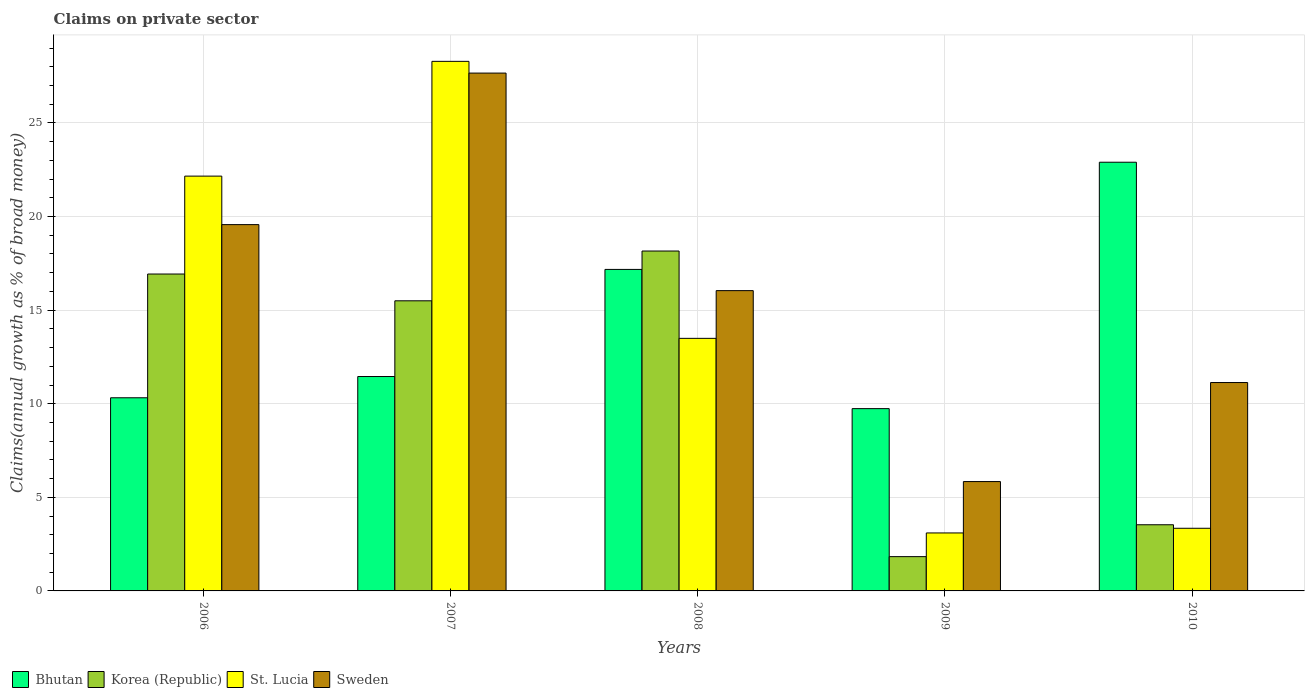How many different coloured bars are there?
Keep it short and to the point. 4. How many groups of bars are there?
Offer a terse response. 5. Are the number of bars on each tick of the X-axis equal?
Your answer should be very brief. Yes. How many bars are there on the 3rd tick from the left?
Give a very brief answer. 4. How many bars are there on the 3rd tick from the right?
Offer a very short reply. 4. What is the label of the 3rd group of bars from the left?
Provide a short and direct response. 2008. In how many cases, is the number of bars for a given year not equal to the number of legend labels?
Keep it short and to the point. 0. What is the percentage of broad money claimed on private sector in St. Lucia in 2008?
Offer a terse response. 13.49. Across all years, what is the maximum percentage of broad money claimed on private sector in Korea (Republic)?
Provide a succinct answer. 18.16. Across all years, what is the minimum percentage of broad money claimed on private sector in Bhutan?
Make the answer very short. 9.74. In which year was the percentage of broad money claimed on private sector in St. Lucia minimum?
Your answer should be very brief. 2009. What is the total percentage of broad money claimed on private sector in Bhutan in the graph?
Make the answer very short. 71.59. What is the difference between the percentage of broad money claimed on private sector in Bhutan in 2007 and that in 2008?
Your answer should be compact. -5.72. What is the difference between the percentage of broad money claimed on private sector in Bhutan in 2007 and the percentage of broad money claimed on private sector in St. Lucia in 2006?
Your response must be concise. -10.71. What is the average percentage of broad money claimed on private sector in Sweden per year?
Your response must be concise. 16.05. In the year 2009, what is the difference between the percentage of broad money claimed on private sector in St. Lucia and percentage of broad money claimed on private sector in Korea (Republic)?
Offer a terse response. 1.27. What is the ratio of the percentage of broad money claimed on private sector in Bhutan in 2006 to that in 2010?
Make the answer very short. 0.45. Is the difference between the percentage of broad money claimed on private sector in St. Lucia in 2008 and 2009 greater than the difference between the percentage of broad money claimed on private sector in Korea (Republic) in 2008 and 2009?
Offer a terse response. No. What is the difference between the highest and the second highest percentage of broad money claimed on private sector in Bhutan?
Keep it short and to the point. 5.73. What is the difference between the highest and the lowest percentage of broad money claimed on private sector in Korea (Republic)?
Your answer should be compact. 16.33. In how many years, is the percentage of broad money claimed on private sector in St. Lucia greater than the average percentage of broad money claimed on private sector in St. Lucia taken over all years?
Your answer should be very brief. 2. What does the 3rd bar from the left in 2008 represents?
Offer a very short reply. St. Lucia. What does the 4th bar from the right in 2007 represents?
Offer a very short reply. Bhutan. Are all the bars in the graph horizontal?
Ensure brevity in your answer.  No. Are the values on the major ticks of Y-axis written in scientific E-notation?
Provide a succinct answer. No. Does the graph contain any zero values?
Your answer should be very brief. No. Does the graph contain grids?
Offer a terse response. Yes. What is the title of the graph?
Provide a succinct answer. Claims on private sector. Does "Turkmenistan" appear as one of the legend labels in the graph?
Your response must be concise. No. What is the label or title of the Y-axis?
Your answer should be very brief. Claims(annual growth as % of broad money). What is the Claims(annual growth as % of broad money) in Bhutan in 2006?
Give a very brief answer. 10.32. What is the Claims(annual growth as % of broad money) in Korea (Republic) in 2006?
Your answer should be very brief. 16.93. What is the Claims(annual growth as % of broad money) in St. Lucia in 2006?
Keep it short and to the point. 22.16. What is the Claims(annual growth as % of broad money) of Sweden in 2006?
Your answer should be compact. 19.57. What is the Claims(annual growth as % of broad money) in Bhutan in 2007?
Make the answer very short. 11.45. What is the Claims(annual growth as % of broad money) of Korea (Republic) in 2007?
Make the answer very short. 15.5. What is the Claims(annual growth as % of broad money) of St. Lucia in 2007?
Your response must be concise. 28.29. What is the Claims(annual growth as % of broad money) of Sweden in 2007?
Your response must be concise. 27.66. What is the Claims(annual growth as % of broad money) in Bhutan in 2008?
Provide a short and direct response. 17.18. What is the Claims(annual growth as % of broad money) in Korea (Republic) in 2008?
Your response must be concise. 18.16. What is the Claims(annual growth as % of broad money) of St. Lucia in 2008?
Your answer should be compact. 13.49. What is the Claims(annual growth as % of broad money) in Sweden in 2008?
Keep it short and to the point. 16.04. What is the Claims(annual growth as % of broad money) in Bhutan in 2009?
Make the answer very short. 9.74. What is the Claims(annual growth as % of broad money) in Korea (Republic) in 2009?
Provide a short and direct response. 1.83. What is the Claims(annual growth as % of broad money) in St. Lucia in 2009?
Provide a succinct answer. 3.1. What is the Claims(annual growth as % of broad money) of Sweden in 2009?
Offer a very short reply. 5.84. What is the Claims(annual growth as % of broad money) of Bhutan in 2010?
Your answer should be compact. 22.9. What is the Claims(annual growth as % of broad money) in Korea (Republic) in 2010?
Provide a succinct answer. 3.53. What is the Claims(annual growth as % of broad money) of St. Lucia in 2010?
Make the answer very short. 3.35. What is the Claims(annual growth as % of broad money) in Sweden in 2010?
Your answer should be very brief. 11.13. Across all years, what is the maximum Claims(annual growth as % of broad money) in Bhutan?
Offer a terse response. 22.9. Across all years, what is the maximum Claims(annual growth as % of broad money) in Korea (Republic)?
Offer a terse response. 18.16. Across all years, what is the maximum Claims(annual growth as % of broad money) in St. Lucia?
Your answer should be compact. 28.29. Across all years, what is the maximum Claims(annual growth as % of broad money) in Sweden?
Offer a very short reply. 27.66. Across all years, what is the minimum Claims(annual growth as % of broad money) in Bhutan?
Offer a terse response. 9.74. Across all years, what is the minimum Claims(annual growth as % of broad money) of Korea (Republic)?
Keep it short and to the point. 1.83. Across all years, what is the minimum Claims(annual growth as % of broad money) in St. Lucia?
Provide a short and direct response. 3.1. Across all years, what is the minimum Claims(annual growth as % of broad money) of Sweden?
Your answer should be very brief. 5.84. What is the total Claims(annual growth as % of broad money) of Bhutan in the graph?
Your response must be concise. 71.59. What is the total Claims(annual growth as % of broad money) in Korea (Republic) in the graph?
Your answer should be compact. 55.95. What is the total Claims(annual growth as % of broad money) of St. Lucia in the graph?
Make the answer very short. 70.39. What is the total Claims(annual growth as % of broad money) of Sweden in the graph?
Keep it short and to the point. 80.25. What is the difference between the Claims(annual growth as % of broad money) of Bhutan in 2006 and that in 2007?
Provide a short and direct response. -1.14. What is the difference between the Claims(annual growth as % of broad money) of Korea (Republic) in 2006 and that in 2007?
Offer a terse response. 1.43. What is the difference between the Claims(annual growth as % of broad money) of St. Lucia in 2006 and that in 2007?
Provide a succinct answer. -6.13. What is the difference between the Claims(annual growth as % of broad money) in Sweden in 2006 and that in 2007?
Your response must be concise. -8.09. What is the difference between the Claims(annual growth as % of broad money) of Bhutan in 2006 and that in 2008?
Your answer should be very brief. -6.86. What is the difference between the Claims(annual growth as % of broad money) in Korea (Republic) in 2006 and that in 2008?
Keep it short and to the point. -1.23. What is the difference between the Claims(annual growth as % of broad money) in St. Lucia in 2006 and that in 2008?
Make the answer very short. 8.67. What is the difference between the Claims(annual growth as % of broad money) of Sweden in 2006 and that in 2008?
Give a very brief answer. 3.53. What is the difference between the Claims(annual growth as % of broad money) in Bhutan in 2006 and that in 2009?
Keep it short and to the point. 0.58. What is the difference between the Claims(annual growth as % of broad money) in Korea (Republic) in 2006 and that in 2009?
Give a very brief answer. 15.1. What is the difference between the Claims(annual growth as % of broad money) of St. Lucia in 2006 and that in 2009?
Make the answer very short. 19.06. What is the difference between the Claims(annual growth as % of broad money) in Sweden in 2006 and that in 2009?
Your answer should be very brief. 13.73. What is the difference between the Claims(annual growth as % of broad money) in Bhutan in 2006 and that in 2010?
Offer a very short reply. -12.58. What is the difference between the Claims(annual growth as % of broad money) of Korea (Republic) in 2006 and that in 2010?
Your answer should be compact. 13.4. What is the difference between the Claims(annual growth as % of broad money) in St. Lucia in 2006 and that in 2010?
Give a very brief answer. 18.81. What is the difference between the Claims(annual growth as % of broad money) of Sweden in 2006 and that in 2010?
Offer a very short reply. 8.44. What is the difference between the Claims(annual growth as % of broad money) of Bhutan in 2007 and that in 2008?
Your response must be concise. -5.72. What is the difference between the Claims(annual growth as % of broad money) of Korea (Republic) in 2007 and that in 2008?
Your response must be concise. -2.66. What is the difference between the Claims(annual growth as % of broad money) of St. Lucia in 2007 and that in 2008?
Your response must be concise. 14.8. What is the difference between the Claims(annual growth as % of broad money) in Sweden in 2007 and that in 2008?
Provide a succinct answer. 11.62. What is the difference between the Claims(annual growth as % of broad money) in Bhutan in 2007 and that in 2009?
Your answer should be compact. 1.72. What is the difference between the Claims(annual growth as % of broad money) of Korea (Republic) in 2007 and that in 2009?
Your answer should be compact. 13.67. What is the difference between the Claims(annual growth as % of broad money) of St. Lucia in 2007 and that in 2009?
Offer a very short reply. 25.19. What is the difference between the Claims(annual growth as % of broad money) of Sweden in 2007 and that in 2009?
Ensure brevity in your answer.  21.82. What is the difference between the Claims(annual growth as % of broad money) of Bhutan in 2007 and that in 2010?
Your response must be concise. -11.45. What is the difference between the Claims(annual growth as % of broad money) of Korea (Republic) in 2007 and that in 2010?
Provide a short and direct response. 11.96. What is the difference between the Claims(annual growth as % of broad money) of St. Lucia in 2007 and that in 2010?
Provide a short and direct response. 24.94. What is the difference between the Claims(annual growth as % of broad money) in Sweden in 2007 and that in 2010?
Give a very brief answer. 16.53. What is the difference between the Claims(annual growth as % of broad money) in Bhutan in 2008 and that in 2009?
Give a very brief answer. 7.44. What is the difference between the Claims(annual growth as % of broad money) of Korea (Republic) in 2008 and that in 2009?
Offer a terse response. 16.33. What is the difference between the Claims(annual growth as % of broad money) in St. Lucia in 2008 and that in 2009?
Make the answer very short. 10.4. What is the difference between the Claims(annual growth as % of broad money) in Sweden in 2008 and that in 2009?
Your response must be concise. 10.2. What is the difference between the Claims(annual growth as % of broad money) in Bhutan in 2008 and that in 2010?
Your answer should be compact. -5.73. What is the difference between the Claims(annual growth as % of broad money) in Korea (Republic) in 2008 and that in 2010?
Your answer should be very brief. 14.62. What is the difference between the Claims(annual growth as % of broad money) in St. Lucia in 2008 and that in 2010?
Ensure brevity in your answer.  10.15. What is the difference between the Claims(annual growth as % of broad money) in Sweden in 2008 and that in 2010?
Provide a short and direct response. 4.91. What is the difference between the Claims(annual growth as % of broad money) in Bhutan in 2009 and that in 2010?
Provide a short and direct response. -13.16. What is the difference between the Claims(annual growth as % of broad money) of Korea (Republic) in 2009 and that in 2010?
Provide a short and direct response. -1.7. What is the difference between the Claims(annual growth as % of broad money) of St. Lucia in 2009 and that in 2010?
Ensure brevity in your answer.  -0.25. What is the difference between the Claims(annual growth as % of broad money) of Sweden in 2009 and that in 2010?
Your answer should be very brief. -5.29. What is the difference between the Claims(annual growth as % of broad money) of Bhutan in 2006 and the Claims(annual growth as % of broad money) of Korea (Republic) in 2007?
Your response must be concise. -5.18. What is the difference between the Claims(annual growth as % of broad money) in Bhutan in 2006 and the Claims(annual growth as % of broad money) in St. Lucia in 2007?
Offer a very short reply. -17.97. What is the difference between the Claims(annual growth as % of broad money) in Bhutan in 2006 and the Claims(annual growth as % of broad money) in Sweden in 2007?
Provide a short and direct response. -17.35. What is the difference between the Claims(annual growth as % of broad money) in Korea (Republic) in 2006 and the Claims(annual growth as % of broad money) in St. Lucia in 2007?
Offer a very short reply. -11.36. What is the difference between the Claims(annual growth as % of broad money) in Korea (Republic) in 2006 and the Claims(annual growth as % of broad money) in Sweden in 2007?
Provide a succinct answer. -10.73. What is the difference between the Claims(annual growth as % of broad money) of St. Lucia in 2006 and the Claims(annual growth as % of broad money) of Sweden in 2007?
Make the answer very short. -5.5. What is the difference between the Claims(annual growth as % of broad money) of Bhutan in 2006 and the Claims(annual growth as % of broad money) of Korea (Republic) in 2008?
Your response must be concise. -7.84. What is the difference between the Claims(annual growth as % of broad money) of Bhutan in 2006 and the Claims(annual growth as % of broad money) of St. Lucia in 2008?
Provide a short and direct response. -3.17. What is the difference between the Claims(annual growth as % of broad money) in Bhutan in 2006 and the Claims(annual growth as % of broad money) in Sweden in 2008?
Provide a short and direct response. -5.72. What is the difference between the Claims(annual growth as % of broad money) of Korea (Republic) in 2006 and the Claims(annual growth as % of broad money) of St. Lucia in 2008?
Ensure brevity in your answer.  3.44. What is the difference between the Claims(annual growth as % of broad money) of Korea (Republic) in 2006 and the Claims(annual growth as % of broad money) of Sweden in 2008?
Keep it short and to the point. 0.89. What is the difference between the Claims(annual growth as % of broad money) in St. Lucia in 2006 and the Claims(annual growth as % of broad money) in Sweden in 2008?
Give a very brief answer. 6.12. What is the difference between the Claims(annual growth as % of broad money) in Bhutan in 2006 and the Claims(annual growth as % of broad money) in Korea (Republic) in 2009?
Give a very brief answer. 8.49. What is the difference between the Claims(annual growth as % of broad money) of Bhutan in 2006 and the Claims(annual growth as % of broad money) of St. Lucia in 2009?
Give a very brief answer. 7.22. What is the difference between the Claims(annual growth as % of broad money) of Bhutan in 2006 and the Claims(annual growth as % of broad money) of Sweden in 2009?
Your answer should be compact. 4.48. What is the difference between the Claims(annual growth as % of broad money) in Korea (Republic) in 2006 and the Claims(annual growth as % of broad money) in St. Lucia in 2009?
Provide a short and direct response. 13.83. What is the difference between the Claims(annual growth as % of broad money) of Korea (Republic) in 2006 and the Claims(annual growth as % of broad money) of Sweden in 2009?
Your answer should be compact. 11.09. What is the difference between the Claims(annual growth as % of broad money) in St. Lucia in 2006 and the Claims(annual growth as % of broad money) in Sweden in 2009?
Offer a very short reply. 16.32. What is the difference between the Claims(annual growth as % of broad money) in Bhutan in 2006 and the Claims(annual growth as % of broad money) in Korea (Republic) in 2010?
Ensure brevity in your answer.  6.78. What is the difference between the Claims(annual growth as % of broad money) of Bhutan in 2006 and the Claims(annual growth as % of broad money) of St. Lucia in 2010?
Keep it short and to the point. 6.97. What is the difference between the Claims(annual growth as % of broad money) in Bhutan in 2006 and the Claims(annual growth as % of broad money) in Sweden in 2010?
Offer a very short reply. -0.81. What is the difference between the Claims(annual growth as % of broad money) of Korea (Republic) in 2006 and the Claims(annual growth as % of broad money) of St. Lucia in 2010?
Make the answer very short. 13.58. What is the difference between the Claims(annual growth as % of broad money) in Korea (Republic) in 2006 and the Claims(annual growth as % of broad money) in Sweden in 2010?
Offer a terse response. 5.8. What is the difference between the Claims(annual growth as % of broad money) of St. Lucia in 2006 and the Claims(annual growth as % of broad money) of Sweden in 2010?
Your response must be concise. 11.03. What is the difference between the Claims(annual growth as % of broad money) in Bhutan in 2007 and the Claims(annual growth as % of broad money) in Korea (Republic) in 2008?
Offer a terse response. -6.7. What is the difference between the Claims(annual growth as % of broad money) of Bhutan in 2007 and the Claims(annual growth as % of broad money) of St. Lucia in 2008?
Keep it short and to the point. -2.04. What is the difference between the Claims(annual growth as % of broad money) in Bhutan in 2007 and the Claims(annual growth as % of broad money) in Sweden in 2008?
Your answer should be very brief. -4.59. What is the difference between the Claims(annual growth as % of broad money) of Korea (Republic) in 2007 and the Claims(annual growth as % of broad money) of St. Lucia in 2008?
Your answer should be compact. 2.01. What is the difference between the Claims(annual growth as % of broad money) of Korea (Republic) in 2007 and the Claims(annual growth as % of broad money) of Sweden in 2008?
Make the answer very short. -0.54. What is the difference between the Claims(annual growth as % of broad money) of St. Lucia in 2007 and the Claims(annual growth as % of broad money) of Sweden in 2008?
Offer a terse response. 12.25. What is the difference between the Claims(annual growth as % of broad money) of Bhutan in 2007 and the Claims(annual growth as % of broad money) of Korea (Republic) in 2009?
Provide a succinct answer. 9.62. What is the difference between the Claims(annual growth as % of broad money) of Bhutan in 2007 and the Claims(annual growth as % of broad money) of St. Lucia in 2009?
Give a very brief answer. 8.36. What is the difference between the Claims(annual growth as % of broad money) in Bhutan in 2007 and the Claims(annual growth as % of broad money) in Sweden in 2009?
Keep it short and to the point. 5.61. What is the difference between the Claims(annual growth as % of broad money) of Korea (Republic) in 2007 and the Claims(annual growth as % of broad money) of St. Lucia in 2009?
Make the answer very short. 12.4. What is the difference between the Claims(annual growth as % of broad money) in Korea (Republic) in 2007 and the Claims(annual growth as % of broad money) in Sweden in 2009?
Provide a succinct answer. 9.66. What is the difference between the Claims(annual growth as % of broad money) in St. Lucia in 2007 and the Claims(annual growth as % of broad money) in Sweden in 2009?
Keep it short and to the point. 22.45. What is the difference between the Claims(annual growth as % of broad money) in Bhutan in 2007 and the Claims(annual growth as % of broad money) in Korea (Republic) in 2010?
Keep it short and to the point. 7.92. What is the difference between the Claims(annual growth as % of broad money) in Bhutan in 2007 and the Claims(annual growth as % of broad money) in St. Lucia in 2010?
Your response must be concise. 8.11. What is the difference between the Claims(annual growth as % of broad money) of Bhutan in 2007 and the Claims(annual growth as % of broad money) of Sweden in 2010?
Offer a very short reply. 0.32. What is the difference between the Claims(annual growth as % of broad money) of Korea (Republic) in 2007 and the Claims(annual growth as % of broad money) of St. Lucia in 2010?
Keep it short and to the point. 12.15. What is the difference between the Claims(annual growth as % of broad money) of Korea (Republic) in 2007 and the Claims(annual growth as % of broad money) of Sweden in 2010?
Offer a terse response. 4.37. What is the difference between the Claims(annual growth as % of broad money) in St. Lucia in 2007 and the Claims(annual growth as % of broad money) in Sweden in 2010?
Give a very brief answer. 17.16. What is the difference between the Claims(annual growth as % of broad money) of Bhutan in 2008 and the Claims(annual growth as % of broad money) of Korea (Republic) in 2009?
Provide a succinct answer. 15.34. What is the difference between the Claims(annual growth as % of broad money) of Bhutan in 2008 and the Claims(annual growth as % of broad money) of St. Lucia in 2009?
Ensure brevity in your answer.  14.08. What is the difference between the Claims(annual growth as % of broad money) of Bhutan in 2008 and the Claims(annual growth as % of broad money) of Sweden in 2009?
Offer a terse response. 11.33. What is the difference between the Claims(annual growth as % of broad money) in Korea (Republic) in 2008 and the Claims(annual growth as % of broad money) in St. Lucia in 2009?
Make the answer very short. 15.06. What is the difference between the Claims(annual growth as % of broad money) of Korea (Republic) in 2008 and the Claims(annual growth as % of broad money) of Sweden in 2009?
Keep it short and to the point. 12.32. What is the difference between the Claims(annual growth as % of broad money) of St. Lucia in 2008 and the Claims(annual growth as % of broad money) of Sweden in 2009?
Keep it short and to the point. 7.65. What is the difference between the Claims(annual growth as % of broad money) in Bhutan in 2008 and the Claims(annual growth as % of broad money) in Korea (Republic) in 2010?
Ensure brevity in your answer.  13.64. What is the difference between the Claims(annual growth as % of broad money) in Bhutan in 2008 and the Claims(annual growth as % of broad money) in St. Lucia in 2010?
Give a very brief answer. 13.83. What is the difference between the Claims(annual growth as % of broad money) of Bhutan in 2008 and the Claims(annual growth as % of broad money) of Sweden in 2010?
Your response must be concise. 6.04. What is the difference between the Claims(annual growth as % of broad money) in Korea (Republic) in 2008 and the Claims(annual growth as % of broad money) in St. Lucia in 2010?
Your response must be concise. 14.81. What is the difference between the Claims(annual growth as % of broad money) in Korea (Republic) in 2008 and the Claims(annual growth as % of broad money) in Sweden in 2010?
Make the answer very short. 7.03. What is the difference between the Claims(annual growth as % of broad money) of St. Lucia in 2008 and the Claims(annual growth as % of broad money) of Sweden in 2010?
Your answer should be compact. 2.36. What is the difference between the Claims(annual growth as % of broad money) of Bhutan in 2009 and the Claims(annual growth as % of broad money) of Korea (Republic) in 2010?
Provide a short and direct response. 6.2. What is the difference between the Claims(annual growth as % of broad money) of Bhutan in 2009 and the Claims(annual growth as % of broad money) of St. Lucia in 2010?
Give a very brief answer. 6.39. What is the difference between the Claims(annual growth as % of broad money) in Bhutan in 2009 and the Claims(annual growth as % of broad money) in Sweden in 2010?
Offer a terse response. -1.39. What is the difference between the Claims(annual growth as % of broad money) of Korea (Republic) in 2009 and the Claims(annual growth as % of broad money) of St. Lucia in 2010?
Provide a succinct answer. -1.52. What is the difference between the Claims(annual growth as % of broad money) of Korea (Republic) in 2009 and the Claims(annual growth as % of broad money) of Sweden in 2010?
Offer a very short reply. -9.3. What is the difference between the Claims(annual growth as % of broad money) in St. Lucia in 2009 and the Claims(annual growth as % of broad money) in Sweden in 2010?
Offer a very short reply. -8.04. What is the average Claims(annual growth as % of broad money) in Bhutan per year?
Give a very brief answer. 14.32. What is the average Claims(annual growth as % of broad money) of Korea (Republic) per year?
Offer a terse response. 11.19. What is the average Claims(annual growth as % of broad money) in St. Lucia per year?
Your answer should be very brief. 14.08. What is the average Claims(annual growth as % of broad money) of Sweden per year?
Provide a succinct answer. 16.05. In the year 2006, what is the difference between the Claims(annual growth as % of broad money) in Bhutan and Claims(annual growth as % of broad money) in Korea (Republic)?
Keep it short and to the point. -6.61. In the year 2006, what is the difference between the Claims(annual growth as % of broad money) of Bhutan and Claims(annual growth as % of broad money) of St. Lucia?
Provide a short and direct response. -11.84. In the year 2006, what is the difference between the Claims(annual growth as % of broad money) of Bhutan and Claims(annual growth as % of broad money) of Sweden?
Ensure brevity in your answer.  -9.25. In the year 2006, what is the difference between the Claims(annual growth as % of broad money) in Korea (Republic) and Claims(annual growth as % of broad money) in St. Lucia?
Provide a short and direct response. -5.23. In the year 2006, what is the difference between the Claims(annual growth as % of broad money) of Korea (Republic) and Claims(annual growth as % of broad money) of Sweden?
Offer a terse response. -2.64. In the year 2006, what is the difference between the Claims(annual growth as % of broad money) in St. Lucia and Claims(annual growth as % of broad money) in Sweden?
Make the answer very short. 2.59. In the year 2007, what is the difference between the Claims(annual growth as % of broad money) of Bhutan and Claims(annual growth as % of broad money) of Korea (Republic)?
Ensure brevity in your answer.  -4.04. In the year 2007, what is the difference between the Claims(annual growth as % of broad money) of Bhutan and Claims(annual growth as % of broad money) of St. Lucia?
Give a very brief answer. -16.84. In the year 2007, what is the difference between the Claims(annual growth as % of broad money) in Bhutan and Claims(annual growth as % of broad money) in Sweden?
Your answer should be compact. -16.21. In the year 2007, what is the difference between the Claims(annual growth as % of broad money) of Korea (Republic) and Claims(annual growth as % of broad money) of St. Lucia?
Provide a short and direct response. -12.79. In the year 2007, what is the difference between the Claims(annual growth as % of broad money) in Korea (Republic) and Claims(annual growth as % of broad money) in Sweden?
Offer a very short reply. -12.17. In the year 2007, what is the difference between the Claims(annual growth as % of broad money) in St. Lucia and Claims(annual growth as % of broad money) in Sweden?
Your answer should be compact. 0.63. In the year 2008, what is the difference between the Claims(annual growth as % of broad money) in Bhutan and Claims(annual growth as % of broad money) in Korea (Republic)?
Make the answer very short. -0.98. In the year 2008, what is the difference between the Claims(annual growth as % of broad money) in Bhutan and Claims(annual growth as % of broad money) in St. Lucia?
Offer a very short reply. 3.68. In the year 2008, what is the difference between the Claims(annual growth as % of broad money) of Bhutan and Claims(annual growth as % of broad money) of Sweden?
Provide a succinct answer. 1.13. In the year 2008, what is the difference between the Claims(annual growth as % of broad money) of Korea (Republic) and Claims(annual growth as % of broad money) of St. Lucia?
Offer a very short reply. 4.67. In the year 2008, what is the difference between the Claims(annual growth as % of broad money) of Korea (Republic) and Claims(annual growth as % of broad money) of Sweden?
Your answer should be compact. 2.12. In the year 2008, what is the difference between the Claims(annual growth as % of broad money) in St. Lucia and Claims(annual growth as % of broad money) in Sweden?
Make the answer very short. -2.55. In the year 2009, what is the difference between the Claims(annual growth as % of broad money) in Bhutan and Claims(annual growth as % of broad money) in Korea (Republic)?
Offer a terse response. 7.91. In the year 2009, what is the difference between the Claims(annual growth as % of broad money) of Bhutan and Claims(annual growth as % of broad money) of St. Lucia?
Make the answer very short. 6.64. In the year 2009, what is the difference between the Claims(annual growth as % of broad money) of Bhutan and Claims(annual growth as % of broad money) of Sweden?
Keep it short and to the point. 3.9. In the year 2009, what is the difference between the Claims(annual growth as % of broad money) in Korea (Republic) and Claims(annual growth as % of broad money) in St. Lucia?
Give a very brief answer. -1.27. In the year 2009, what is the difference between the Claims(annual growth as % of broad money) in Korea (Republic) and Claims(annual growth as % of broad money) in Sweden?
Make the answer very short. -4.01. In the year 2009, what is the difference between the Claims(annual growth as % of broad money) in St. Lucia and Claims(annual growth as % of broad money) in Sweden?
Your answer should be very brief. -2.74. In the year 2010, what is the difference between the Claims(annual growth as % of broad money) of Bhutan and Claims(annual growth as % of broad money) of Korea (Republic)?
Give a very brief answer. 19.37. In the year 2010, what is the difference between the Claims(annual growth as % of broad money) in Bhutan and Claims(annual growth as % of broad money) in St. Lucia?
Provide a short and direct response. 19.56. In the year 2010, what is the difference between the Claims(annual growth as % of broad money) in Bhutan and Claims(annual growth as % of broad money) in Sweden?
Offer a very short reply. 11.77. In the year 2010, what is the difference between the Claims(annual growth as % of broad money) of Korea (Republic) and Claims(annual growth as % of broad money) of St. Lucia?
Your answer should be very brief. 0.19. In the year 2010, what is the difference between the Claims(annual growth as % of broad money) in Korea (Republic) and Claims(annual growth as % of broad money) in Sweden?
Provide a short and direct response. -7.6. In the year 2010, what is the difference between the Claims(annual growth as % of broad money) in St. Lucia and Claims(annual growth as % of broad money) in Sweden?
Ensure brevity in your answer.  -7.79. What is the ratio of the Claims(annual growth as % of broad money) of Bhutan in 2006 to that in 2007?
Make the answer very short. 0.9. What is the ratio of the Claims(annual growth as % of broad money) of Korea (Republic) in 2006 to that in 2007?
Your answer should be compact. 1.09. What is the ratio of the Claims(annual growth as % of broad money) of St. Lucia in 2006 to that in 2007?
Offer a very short reply. 0.78. What is the ratio of the Claims(annual growth as % of broad money) in Sweden in 2006 to that in 2007?
Give a very brief answer. 0.71. What is the ratio of the Claims(annual growth as % of broad money) of Bhutan in 2006 to that in 2008?
Provide a succinct answer. 0.6. What is the ratio of the Claims(annual growth as % of broad money) of Korea (Republic) in 2006 to that in 2008?
Your response must be concise. 0.93. What is the ratio of the Claims(annual growth as % of broad money) of St. Lucia in 2006 to that in 2008?
Your answer should be compact. 1.64. What is the ratio of the Claims(annual growth as % of broad money) in Sweden in 2006 to that in 2008?
Your answer should be very brief. 1.22. What is the ratio of the Claims(annual growth as % of broad money) of Bhutan in 2006 to that in 2009?
Your response must be concise. 1.06. What is the ratio of the Claims(annual growth as % of broad money) in Korea (Republic) in 2006 to that in 2009?
Keep it short and to the point. 9.24. What is the ratio of the Claims(annual growth as % of broad money) of St. Lucia in 2006 to that in 2009?
Keep it short and to the point. 7.16. What is the ratio of the Claims(annual growth as % of broad money) of Sweden in 2006 to that in 2009?
Keep it short and to the point. 3.35. What is the ratio of the Claims(annual growth as % of broad money) in Bhutan in 2006 to that in 2010?
Ensure brevity in your answer.  0.45. What is the ratio of the Claims(annual growth as % of broad money) of Korea (Republic) in 2006 to that in 2010?
Provide a succinct answer. 4.79. What is the ratio of the Claims(annual growth as % of broad money) of St. Lucia in 2006 to that in 2010?
Your answer should be very brief. 6.62. What is the ratio of the Claims(annual growth as % of broad money) in Sweden in 2006 to that in 2010?
Ensure brevity in your answer.  1.76. What is the ratio of the Claims(annual growth as % of broad money) of Bhutan in 2007 to that in 2008?
Offer a very short reply. 0.67. What is the ratio of the Claims(annual growth as % of broad money) of Korea (Republic) in 2007 to that in 2008?
Ensure brevity in your answer.  0.85. What is the ratio of the Claims(annual growth as % of broad money) in St. Lucia in 2007 to that in 2008?
Keep it short and to the point. 2.1. What is the ratio of the Claims(annual growth as % of broad money) of Sweden in 2007 to that in 2008?
Your answer should be compact. 1.72. What is the ratio of the Claims(annual growth as % of broad money) in Bhutan in 2007 to that in 2009?
Provide a short and direct response. 1.18. What is the ratio of the Claims(annual growth as % of broad money) of Korea (Republic) in 2007 to that in 2009?
Your answer should be very brief. 8.46. What is the ratio of the Claims(annual growth as % of broad money) in St. Lucia in 2007 to that in 2009?
Offer a terse response. 9.13. What is the ratio of the Claims(annual growth as % of broad money) of Sweden in 2007 to that in 2009?
Give a very brief answer. 4.74. What is the ratio of the Claims(annual growth as % of broad money) of Bhutan in 2007 to that in 2010?
Offer a terse response. 0.5. What is the ratio of the Claims(annual growth as % of broad money) of Korea (Republic) in 2007 to that in 2010?
Provide a short and direct response. 4.38. What is the ratio of the Claims(annual growth as % of broad money) in St. Lucia in 2007 to that in 2010?
Your answer should be very brief. 8.45. What is the ratio of the Claims(annual growth as % of broad money) of Sweden in 2007 to that in 2010?
Offer a terse response. 2.49. What is the ratio of the Claims(annual growth as % of broad money) in Bhutan in 2008 to that in 2009?
Keep it short and to the point. 1.76. What is the ratio of the Claims(annual growth as % of broad money) in Korea (Republic) in 2008 to that in 2009?
Keep it short and to the point. 9.91. What is the ratio of the Claims(annual growth as % of broad money) in St. Lucia in 2008 to that in 2009?
Give a very brief answer. 4.36. What is the ratio of the Claims(annual growth as % of broad money) of Sweden in 2008 to that in 2009?
Make the answer very short. 2.75. What is the ratio of the Claims(annual growth as % of broad money) in Korea (Republic) in 2008 to that in 2010?
Your answer should be very brief. 5.14. What is the ratio of the Claims(annual growth as % of broad money) of St. Lucia in 2008 to that in 2010?
Make the answer very short. 4.03. What is the ratio of the Claims(annual growth as % of broad money) in Sweden in 2008 to that in 2010?
Offer a terse response. 1.44. What is the ratio of the Claims(annual growth as % of broad money) in Bhutan in 2009 to that in 2010?
Your answer should be very brief. 0.43. What is the ratio of the Claims(annual growth as % of broad money) in Korea (Republic) in 2009 to that in 2010?
Your response must be concise. 0.52. What is the ratio of the Claims(annual growth as % of broad money) of St. Lucia in 2009 to that in 2010?
Give a very brief answer. 0.93. What is the ratio of the Claims(annual growth as % of broad money) in Sweden in 2009 to that in 2010?
Your answer should be compact. 0.52. What is the difference between the highest and the second highest Claims(annual growth as % of broad money) in Bhutan?
Your response must be concise. 5.73. What is the difference between the highest and the second highest Claims(annual growth as % of broad money) of Korea (Republic)?
Provide a succinct answer. 1.23. What is the difference between the highest and the second highest Claims(annual growth as % of broad money) of St. Lucia?
Make the answer very short. 6.13. What is the difference between the highest and the second highest Claims(annual growth as % of broad money) in Sweden?
Offer a terse response. 8.09. What is the difference between the highest and the lowest Claims(annual growth as % of broad money) of Bhutan?
Keep it short and to the point. 13.16. What is the difference between the highest and the lowest Claims(annual growth as % of broad money) in Korea (Republic)?
Provide a short and direct response. 16.33. What is the difference between the highest and the lowest Claims(annual growth as % of broad money) in St. Lucia?
Keep it short and to the point. 25.19. What is the difference between the highest and the lowest Claims(annual growth as % of broad money) in Sweden?
Your response must be concise. 21.82. 